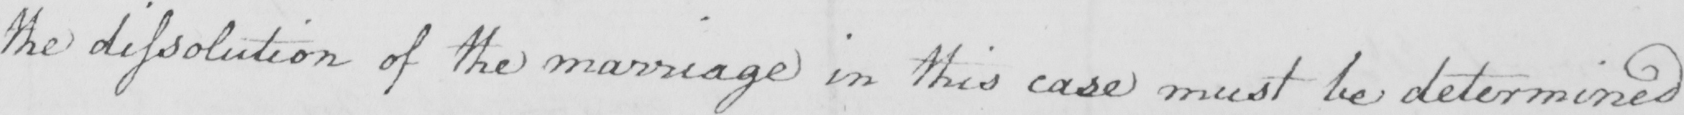Transcribe the text shown in this historical manuscript line. the dissolution of the marriage in this case must be determined 